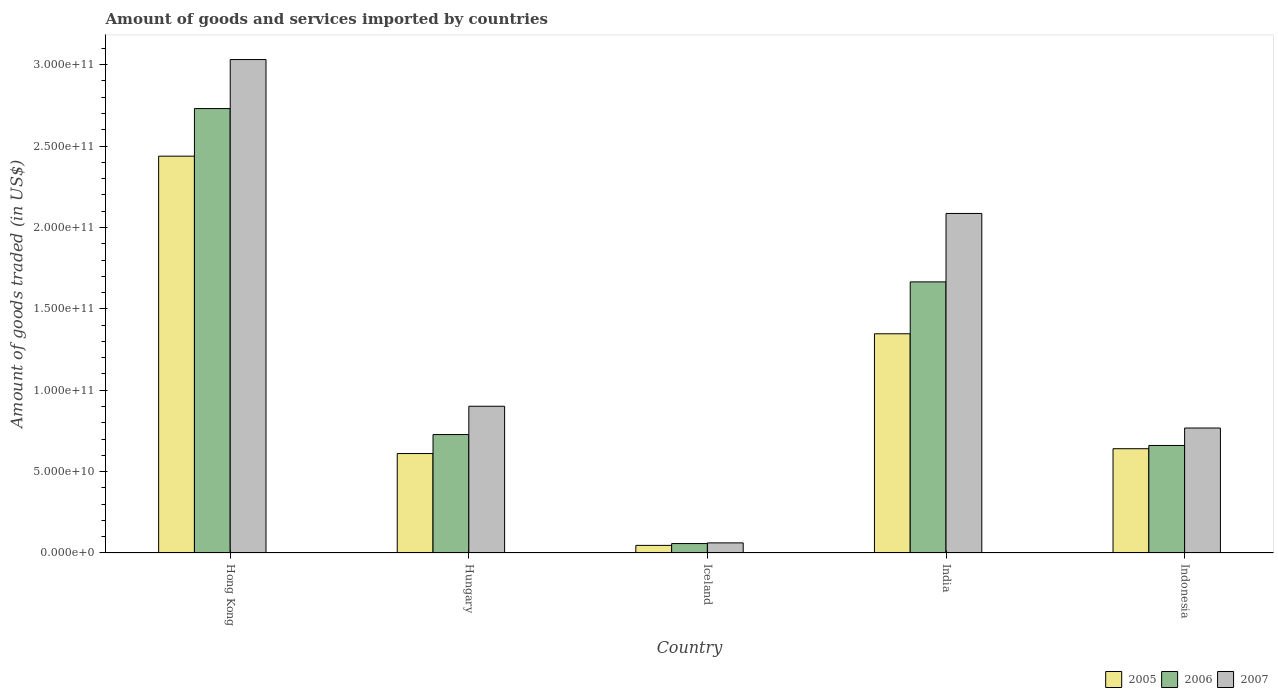How many different coloured bars are there?
Your answer should be very brief. 3. How many groups of bars are there?
Ensure brevity in your answer.  5. How many bars are there on the 5th tick from the left?
Ensure brevity in your answer.  3. How many bars are there on the 1st tick from the right?
Make the answer very short. 3. What is the label of the 2nd group of bars from the left?
Your answer should be compact. Hungary. What is the total amount of goods and services imported in 2007 in India?
Your answer should be compact. 2.09e+11. Across all countries, what is the maximum total amount of goods and services imported in 2005?
Provide a succinct answer. 2.44e+11. Across all countries, what is the minimum total amount of goods and services imported in 2005?
Keep it short and to the point. 4.67e+09. In which country was the total amount of goods and services imported in 2005 maximum?
Provide a short and direct response. Hong Kong. In which country was the total amount of goods and services imported in 2006 minimum?
Your answer should be compact. Iceland. What is the total total amount of goods and services imported in 2007 in the graph?
Give a very brief answer. 6.85e+11. What is the difference between the total amount of goods and services imported in 2005 in Hong Kong and that in Hungary?
Provide a short and direct response. 1.83e+11. What is the difference between the total amount of goods and services imported in 2006 in India and the total amount of goods and services imported in 2007 in Hong Kong?
Your response must be concise. -1.37e+11. What is the average total amount of goods and services imported in 2006 per country?
Make the answer very short. 1.17e+11. What is the difference between the total amount of goods and services imported of/in 2007 and total amount of goods and services imported of/in 2005 in Iceland?
Offer a terse response. 1.54e+09. What is the ratio of the total amount of goods and services imported in 2007 in Hong Kong to that in Hungary?
Provide a succinct answer. 3.36. What is the difference between the highest and the second highest total amount of goods and services imported in 2005?
Keep it short and to the point. 1.09e+11. What is the difference between the highest and the lowest total amount of goods and services imported in 2005?
Make the answer very short. 2.39e+11. In how many countries, is the total amount of goods and services imported in 2007 greater than the average total amount of goods and services imported in 2007 taken over all countries?
Ensure brevity in your answer.  2. What does the 2nd bar from the left in Indonesia represents?
Your answer should be compact. 2006. How many bars are there?
Give a very brief answer. 15. What is the difference between two consecutive major ticks on the Y-axis?
Ensure brevity in your answer.  5.00e+1. Are the values on the major ticks of Y-axis written in scientific E-notation?
Offer a terse response. Yes. Does the graph contain grids?
Your answer should be compact. No. How many legend labels are there?
Provide a succinct answer. 3. How are the legend labels stacked?
Your answer should be compact. Horizontal. What is the title of the graph?
Your answer should be compact. Amount of goods and services imported by countries. Does "1973" appear as one of the legend labels in the graph?
Your answer should be compact. No. What is the label or title of the Y-axis?
Give a very brief answer. Amount of goods traded (in US$). What is the Amount of goods traded (in US$) in 2005 in Hong Kong?
Keep it short and to the point. 2.44e+11. What is the Amount of goods traded (in US$) in 2006 in Hong Kong?
Your answer should be very brief. 2.73e+11. What is the Amount of goods traded (in US$) in 2007 in Hong Kong?
Provide a short and direct response. 3.03e+11. What is the Amount of goods traded (in US$) of 2005 in Hungary?
Provide a succinct answer. 6.11e+1. What is the Amount of goods traded (in US$) of 2006 in Hungary?
Provide a short and direct response. 7.28e+1. What is the Amount of goods traded (in US$) of 2007 in Hungary?
Keep it short and to the point. 9.02e+1. What is the Amount of goods traded (in US$) in 2005 in Iceland?
Offer a terse response. 4.67e+09. What is the Amount of goods traded (in US$) in 2006 in Iceland?
Ensure brevity in your answer.  5.79e+09. What is the Amount of goods traded (in US$) of 2007 in Iceland?
Offer a very short reply. 6.21e+09. What is the Amount of goods traded (in US$) in 2005 in India?
Your response must be concise. 1.35e+11. What is the Amount of goods traded (in US$) in 2006 in India?
Your answer should be very brief. 1.67e+11. What is the Amount of goods traded (in US$) of 2007 in India?
Your response must be concise. 2.09e+11. What is the Amount of goods traded (in US$) in 2005 in Indonesia?
Your answer should be very brief. 6.41e+1. What is the Amount of goods traded (in US$) in 2006 in Indonesia?
Offer a very short reply. 6.61e+1. What is the Amount of goods traded (in US$) in 2007 in Indonesia?
Provide a short and direct response. 7.68e+1. Across all countries, what is the maximum Amount of goods traded (in US$) of 2005?
Ensure brevity in your answer.  2.44e+11. Across all countries, what is the maximum Amount of goods traded (in US$) of 2006?
Offer a very short reply. 2.73e+11. Across all countries, what is the maximum Amount of goods traded (in US$) of 2007?
Offer a terse response. 3.03e+11. Across all countries, what is the minimum Amount of goods traded (in US$) of 2005?
Provide a short and direct response. 4.67e+09. Across all countries, what is the minimum Amount of goods traded (in US$) of 2006?
Keep it short and to the point. 5.79e+09. Across all countries, what is the minimum Amount of goods traded (in US$) in 2007?
Offer a terse response. 6.21e+09. What is the total Amount of goods traded (in US$) of 2005 in the graph?
Provide a succinct answer. 5.08e+11. What is the total Amount of goods traded (in US$) in 2006 in the graph?
Offer a terse response. 5.84e+11. What is the total Amount of goods traded (in US$) of 2007 in the graph?
Keep it short and to the point. 6.85e+11. What is the difference between the Amount of goods traded (in US$) in 2005 in Hong Kong and that in Hungary?
Ensure brevity in your answer.  1.83e+11. What is the difference between the Amount of goods traded (in US$) in 2006 in Hong Kong and that in Hungary?
Your answer should be compact. 2.00e+11. What is the difference between the Amount of goods traded (in US$) in 2007 in Hong Kong and that in Hungary?
Provide a short and direct response. 2.13e+11. What is the difference between the Amount of goods traded (in US$) of 2005 in Hong Kong and that in Iceland?
Offer a very short reply. 2.39e+11. What is the difference between the Amount of goods traded (in US$) of 2006 in Hong Kong and that in Iceland?
Your response must be concise. 2.67e+11. What is the difference between the Amount of goods traded (in US$) of 2007 in Hong Kong and that in Iceland?
Provide a succinct answer. 2.97e+11. What is the difference between the Amount of goods traded (in US$) of 2005 in Hong Kong and that in India?
Offer a very short reply. 1.09e+11. What is the difference between the Amount of goods traded (in US$) of 2006 in Hong Kong and that in India?
Make the answer very short. 1.06e+11. What is the difference between the Amount of goods traded (in US$) in 2007 in Hong Kong and that in India?
Your answer should be compact. 9.46e+1. What is the difference between the Amount of goods traded (in US$) of 2005 in Hong Kong and that in Indonesia?
Keep it short and to the point. 1.80e+11. What is the difference between the Amount of goods traded (in US$) of 2006 in Hong Kong and that in Indonesia?
Offer a terse response. 2.07e+11. What is the difference between the Amount of goods traded (in US$) of 2007 in Hong Kong and that in Indonesia?
Keep it short and to the point. 2.26e+11. What is the difference between the Amount of goods traded (in US$) in 2005 in Hungary and that in Iceland?
Ensure brevity in your answer.  5.64e+1. What is the difference between the Amount of goods traded (in US$) of 2006 in Hungary and that in Iceland?
Ensure brevity in your answer.  6.70e+1. What is the difference between the Amount of goods traded (in US$) in 2007 in Hungary and that in Iceland?
Keep it short and to the point. 8.39e+1. What is the difference between the Amount of goods traded (in US$) in 2005 in Hungary and that in India?
Offer a terse response. -7.36e+1. What is the difference between the Amount of goods traded (in US$) of 2006 in Hungary and that in India?
Give a very brief answer. -9.38e+1. What is the difference between the Amount of goods traded (in US$) in 2007 in Hungary and that in India?
Provide a succinct answer. -1.18e+11. What is the difference between the Amount of goods traded (in US$) of 2005 in Hungary and that in Indonesia?
Keep it short and to the point. -2.97e+09. What is the difference between the Amount of goods traded (in US$) in 2006 in Hungary and that in Indonesia?
Offer a very short reply. 6.71e+09. What is the difference between the Amount of goods traded (in US$) of 2007 in Hungary and that in Indonesia?
Ensure brevity in your answer.  1.34e+1. What is the difference between the Amount of goods traded (in US$) in 2005 in Iceland and that in India?
Provide a succinct answer. -1.30e+11. What is the difference between the Amount of goods traded (in US$) in 2006 in Iceland and that in India?
Ensure brevity in your answer.  -1.61e+11. What is the difference between the Amount of goods traded (in US$) in 2007 in Iceland and that in India?
Give a very brief answer. -2.02e+11. What is the difference between the Amount of goods traded (in US$) of 2005 in Iceland and that in Indonesia?
Give a very brief answer. -5.94e+1. What is the difference between the Amount of goods traded (in US$) in 2006 in Iceland and that in Indonesia?
Your response must be concise. -6.03e+1. What is the difference between the Amount of goods traded (in US$) in 2007 in Iceland and that in Indonesia?
Make the answer very short. -7.06e+1. What is the difference between the Amount of goods traded (in US$) in 2005 in India and that in Indonesia?
Keep it short and to the point. 7.06e+1. What is the difference between the Amount of goods traded (in US$) of 2006 in India and that in Indonesia?
Offer a very short reply. 1.01e+11. What is the difference between the Amount of goods traded (in US$) of 2007 in India and that in Indonesia?
Provide a short and direct response. 1.32e+11. What is the difference between the Amount of goods traded (in US$) of 2005 in Hong Kong and the Amount of goods traded (in US$) of 2006 in Hungary?
Offer a terse response. 1.71e+11. What is the difference between the Amount of goods traded (in US$) in 2005 in Hong Kong and the Amount of goods traded (in US$) in 2007 in Hungary?
Your response must be concise. 1.54e+11. What is the difference between the Amount of goods traded (in US$) in 2006 in Hong Kong and the Amount of goods traded (in US$) in 2007 in Hungary?
Your answer should be very brief. 1.83e+11. What is the difference between the Amount of goods traded (in US$) of 2005 in Hong Kong and the Amount of goods traded (in US$) of 2006 in Iceland?
Your answer should be very brief. 2.38e+11. What is the difference between the Amount of goods traded (in US$) of 2005 in Hong Kong and the Amount of goods traded (in US$) of 2007 in Iceland?
Provide a short and direct response. 2.38e+11. What is the difference between the Amount of goods traded (in US$) in 2006 in Hong Kong and the Amount of goods traded (in US$) in 2007 in Iceland?
Make the answer very short. 2.67e+11. What is the difference between the Amount of goods traded (in US$) in 2005 in Hong Kong and the Amount of goods traded (in US$) in 2006 in India?
Provide a succinct answer. 7.72e+1. What is the difference between the Amount of goods traded (in US$) of 2005 in Hong Kong and the Amount of goods traded (in US$) of 2007 in India?
Your answer should be very brief. 3.52e+1. What is the difference between the Amount of goods traded (in US$) in 2006 in Hong Kong and the Amount of goods traded (in US$) in 2007 in India?
Keep it short and to the point. 6.44e+1. What is the difference between the Amount of goods traded (in US$) in 2005 in Hong Kong and the Amount of goods traded (in US$) in 2006 in Indonesia?
Your answer should be compact. 1.78e+11. What is the difference between the Amount of goods traded (in US$) of 2005 in Hong Kong and the Amount of goods traded (in US$) of 2007 in Indonesia?
Provide a succinct answer. 1.67e+11. What is the difference between the Amount of goods traded (in US$) of 2006 in Hong Kong and the Amount of goods traded (in US$) of 2007 in Indonesia?
Your answer should be compact. 1.96e+11. What is the difference between the Amount of goods traded (in US$) of 2005 in Hungary and the Amount of goods traded (in US$) of 2006 in Iceland?
Make the answer very short. 5.53e+1. What is the difference between the Amount of goods traded (in US$) in 2005 in Hungary and the Amount of goods traded (in US$) in 2007 in Iceland?
Your answer should be compact. 5.49e+1. What is the difference between the Amount of goods traded (in US$) in 2006 in Hungary and the Amount of goods traded (in US$) in 2007 in Iceland?
Ensure brevity in your answer.  6.66e+1. What is the difference between the Amount of goods traded (in US$) of 2005 in Hungary and the Amount of goods traded (in US$) of 2006 in India?
Provide a succinct answer. -1.05e+11. What is the difference between the Amount of goods traded (in US$) of 2005 in Hungary and the Amount of goods traded (in US$) of 2007 in India?
Your answer should be compact. -1.48e+11. What is the difference between the Amount of goods traded (in US$) in 2006 in Hungary and the Amount of goods traded (in US$) in 2007 in India?
Make the answer very short. -1.36e+11. What is the difference between the Amount of goods traded (in US$) in 2005 in Hungary and the Amount of goods traded (in US$) in 2006 in Indonesia?
Give a very brief answer. -4.95e+09. What is the difference between the Amount of goods traded (in US$) of 2005 in Hungary and the Amount of goods traded (in US$) of 2007 in Indonesia?
Your response must be concise. -1.57e+1. What is the difference between the Amount of goods traded (in US$) in 2006 in Hungary and the Amount of goods traded (in US$) in 2007 in Indonesia?
Keep it short and to the point. -4.01e+09. What is the difference between the Amount of goods traded (in US$) of 2005 in Iceland and the Amount of goods traded (in US$) of 2006 in India?
Give a very brief answer. -1.62e+11. What is the difference between the Amount of goods traded (in US$) in 2005 in Iceland and the Amount of goods traded (in US$) in 2007 in India?
Provide a succinct answer. -2.04e+11. What is the difference between the Amount of goods traded (in US$) in 2006 in Iceland and the Amount of goods traded (in US$) in 2007 in India?
Offer a very short reply. -2.03e+11. What is the difference between the Amount of goods traded (in US$) of 2005 in Iceland and the Amount of goods traded (in US$) of 2006 in Indonesia?
Provide a succinct answer. -6.14e+1. What is the difference between the Amount of goods traded (in US$) of 2005 in Iceland and the Amount of goods traded (in US$) of 2007 in Indonesia?
Your answer should be very brief. -7.21e+1. What is the difference between the Amount of goods traded (in US$) in 2006 in Iceland and the Amount of goods traded (in US$) in 2007 in Indonesia?
Keep it short and to the point. -7.10e+1. What is the difference between the Amount of goods traded (in US$) in 2005 in India and the Amount of goods traded (in US$) in 2006 in Indonesia?
Provide a short and direct response. 6.86e+1. What is the difference between the Amount of goods traded (in US$) of 2005 in India and the Amount of goods traded (in US$) of 2007 in Indonesia?
Provide a succinct answer. 5.79e+1. What is the difference between the Amount of goods traded (in US$) of 2006 in India and the Amount of goods traded (in US$) of 2007 in Indonesia?
Provide a succinct answer. 8.98e+1. What is the average Amount of goods traded (in US$) of 2005 per country?
Your answer should be very brief. 1.02e+11. What is the average Amount of goods traded (in US$) in 2006 per country?
Offer a terse response. 1.17e+11. What is the average Amount of goods traded (in US$) of 2007 per country?
Make the answer very short. 1.37e+11. What is the difference between the Amount of goods traded (in US$) of 2005 and Amount of goods traded (in US$) of 2006 in Hong Kong?
Your answer should be very brief. -2.92e+1. What is the difference between the Amount of goods traded (in US$) of 2005 and Amount of goods traded (in US$) of 2007 in Hong Kong?
Make the answer very short. -5.94e+1. What is the difference between the Amount of goods traded (in US$) in 2006 and Amount of goods traded (in US$) in 2007 in Hong Kong?
Ensure brevity in your answer.  -3.01e+1. What is the difference between the Amount of goods traded (in US$) in 2005 and Amount of goods traded (in US$) in 2006 in Hungary?
Ensure brevity in your answer.  -1.17e+1. What is the difference between the Amount of goods traded (in US$) of 2005 and Amount of goods traded (in US$) of 2007 in Hungary?
Provide a short and direct response. -2.91e+1. What is the difference between the Amount of goods traded (in US$) of 2006 and Amount of goods traded (in US$) of 2007 in Hungary?
Provide a short and direct response. -1.74e+1. What is the difference between the Amount of goods traded (in US$) of 2005 and Amount of goods traded (in US$) of 2006 in Iceland?
Make the answer very short. -1.12e+09. What is the difference between the Amount of goods traded (in US$) in 2005 and Amount of goods traded (in US$) in 2007 in Iceland?
Your answer should be very brief. -1.54e+09. What is the difference between the Amount of goods traded (in US$) of 2006 and Amount of goods traded (in US$) of 2007 in Iceland?
Give a very brief answer. -4.23e+08. What is the difference between the Amount of goods traded (in US$) of 2005 and Amount of goods traded (in US$) of 2006 in India?
Your response must be concise. -3.19e+1. What is the difference between the Amount of goods traded (in US$) in 2005 and Amount of goods traded (in US$) in 2007 in India?
Keep it short and to the point. -7.39e+1. What is the difference between the Amount of goods traded (in US$) of 2006 and Amount of goods traded (in US$) of 2007 in India?
Keep it short and to the point. -4.20e+1. What is the difference between the Amount of goods traded (in US$) of 2005 and Amount of goods traded (in US$) of 2006 in Indonesia?
Provide a succinct answer. -1.98e+09. What is the difference between the Amount of goods traded (in US$) of 2005 and Amount of goods traded (in US$) of 2007 in Indonesia?
Make the answer very short. -1.27e+1. What is the difference between the Amount of goods traded (in US$) in 2006 and Amount of goods traded (in US$) in 2007 in Indonesia?
Give a very brief answer. -1.07e+1. What is the ratio of the Amount of goods traded (in US$) in 2005 in Hong Kong to that in Hungary?
Give a very brief answer. 3.99. What is the ratio of the Amount of goods traded (in US$) in 2006 in Hong Kong to that in Hungary?
Keep it short and to the point. 3.75. What is the ratio of the Amount of goods traded (in US$) in 2007 in Hong Kong to that in Hungary?
Make the answer very short. 3.36. What is the ratio of the Amount of goods traded (in US$) in 2005 in Hong Kong to that in Iceland?
Your answer should be compact. 52.23. What is the ratio of the Amount of goods traded (in US$) of 2006 in Hong Kong to that in Iceland?
Offer a terse response. 47.18. What is the ratio of the Amount of goods traded (in US$) in 2007 in Hong Kong to that in Iceland?
Your answer should be very brief. 48.82. What is the ratio of the Amount of goods traded (in US$) in 2005 in Hong Kong to that in India?
Give a very brief answer. 1.81. What is the ratio of the Amount of goods traded (in US$) in 2006 in Hong Kong to that in India?
Make the answer very short. 1.64. What is the ratio of the Amount of goods traded (in US$) in 2007 in Hong Kong to that in India?
Provide a short and direct response. 1.45. What is the ratio of the Amount of goods traded (in US$) in 2005 in Hong Kong to that in Indonesia?
Provide a succinct answer. 3.81. What is the ratio of the Amount of goods traded (in US$) of 2006 in Hong Kong to that in Indonesia?
Your answer should be compact. 4.13. What is the ratio of the Amount of goods traded (in US$) of 2007 in Hong Kong to that in Indonesia?
Give a very brief answer. 3.95. What is the ratio of the Amount of goods traded (in US$) in 2005 in Hungary to that in Iceland?
Keep it short and to the point. 13.09. What is the ratio of the Amount of goods traded (in US$) of 2006 in Hungary to that in Iceland?
Your response must be concise. 12.57. What is the ratio of the Amount of goods traded (in US$) of 2007 in Hungary to that in Iceland?
Make the answer very short. 14.52. What is the ratio of the Amount of goods traded (in US$) in 2005 in Hungary to that in India?
Keep it short and to the point. 0.45. What is the ratio of the Amount of goods traded (in US$) of 2006 in Hungary to that in India?
Offer a very short reply. 0.44. What is the ratio of the Amount of goods traded (in US$) in 2007 in Hungary to that in India?
Your response must be concise. 0.43. What is the ratio of the Amount of goods traded (in US$) in 2005 in Hungary to that in Indonesia?
Keep it short and to the point. 0.95. What is the ratio of the Amount of goods traded (in US$) in 2006 in Hungary to that in Indonesia?
Make the answer very short. 1.1. What is the ratio of the Amount of goods traded (in US$) in 2007 in Hungary to that in Indonesia?
Your response must be concise. 1.17. What is the ratio of the Amount of goods traded (in US$) of 2005 in Iceland to that in India?
Offer a very short reply. 0.03. What is the ratio of the Amount of goods traded (in US$) of 2006 in Iceland to that in India?
Provide a short and direct response. 0.03. What is the ratio of the Amount of goods traded (in US$) in 2007 in Iceland to that in India?
Ensure brevity in your answer.  0.03. What is the ratio of the Amount of goods traded (in US$) in 2005 in Iceland to that in Indonesia?
Provide a succinct answer. 0.07. What is the ratio of the Amount of goods traded (in US$) in 2006 in Iceland to that in Indonesia?
Offer a very short reply. 0.09. What is the ratio of the Amount of goods traded (in US$) in 2007 in Iceland to that in Indonesia?
Provide a succinct answer. 0.08. What is the ratio of the Amount of goods traded (in US$) of 2005 in India to that in Indonesia?
Offer a terse response. 2.1. What is the ratio of the Amount of goods traded (in US$) in 2006 in India to that in Indonesia?
Keep it short and to the point. 2.52. What is the ratio of the Amount of goods traded (in US$) of 2007 in India to that in Indonesia?
Offer a terse response. 2.72. What is the difference between the highest and the second highest Amount of goods traded (in US$) of 2005?
Your answer should be very brief. 1.09e+11. What is the difference between the highest and the second highest Amount of goods traded (in US$) of 2006?
Your response must be concise. 1.06e+11. What is the difference between the highest and the second highest Amount of goods traded (in US$) in 2007?
Your answer should be very brief. 9.46e+1. What is the difference between the highest and the lowest Amount of goods traded (in US$) of 2005?
Your response must be concise. 2.39e+11. What is the difference between the highest and the lowest Amount of goods traded (in US$) in 2006?
Give a very brief answer. 2.67e+11. What is the difference between the highest and the lowest Amount of goods traded (in US$) in 2007?
Provide a succinct answer. 2.97e+11. 